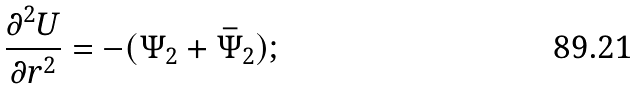<formula> <loc_0><loc_0><loc_500><loc_500>\frac { \partial ^ { 2 } U } { \partial r ^ { 2 } } = - ( \Psi _ { 2 } + \bar { \Psi } _ { 2 } ) ;</formula> 